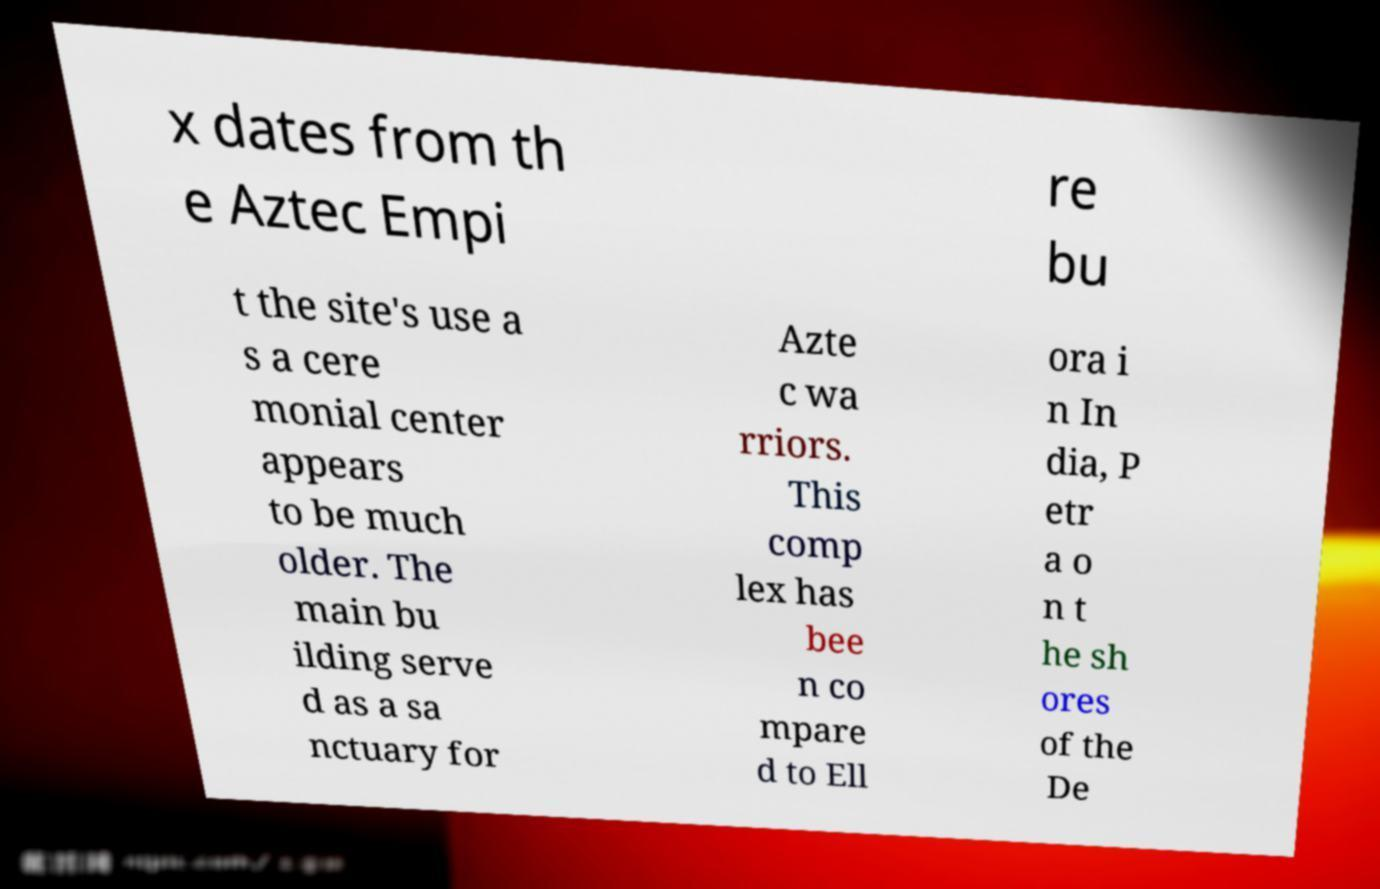Please read and relay the text visible in this image. What does it say? x dates from th e Aztec Empi re bu t the site's use a s a cere monial center appears to be much older. The main bu ilding serve d as a sa nctuary for Azte c wa rriors. This comp lex has bee n co mpare d to Ell ora i n In dia, P etr a o n t he sh ores of the De 